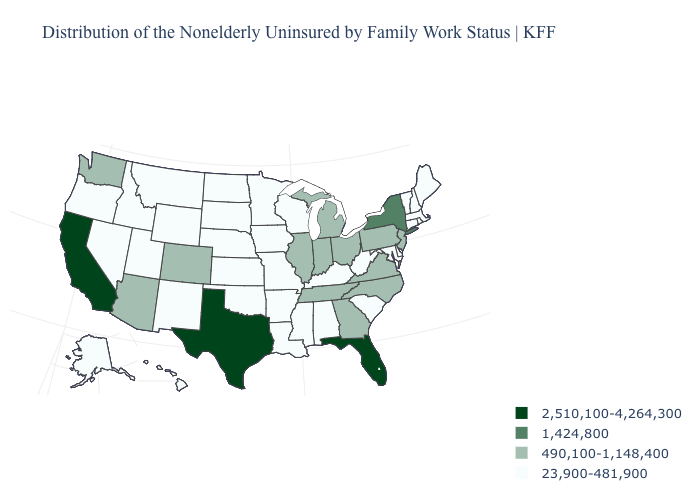Does the map have missing data?
Short answer required. No. How many symbols are there in the legend?
Concise answer only. 4. What is the value of Wisconsin?
Answer briefly. 23,900-481,900. Which states have the lowest value in the USA?
Keep it brief. Alabama, Alaska, Arkansas, Connecticut, Delaware, Hawaii, Idaho, Iowa, Kansas, Kentucky, Louisiana, Maine, Maryland, Massachusetts, Minnesota, Mississippi, Missouri, Montana, Nebraska, Nevada, New Hampshire, New Mexico, North Dakota, Oklahoma, Oregon, Rhode Island, South Carolina, South Dakota, Utah, Vermont, West Virginia, Wisconsin, Wyoming. Does Virginia have a lower value than Florida?
Write a very short answer. Yes. Among the states that border Iowa , does Nebraska have the lowest value?
Be succinct. Yes. Does the map have missing data?
Be succinct. No. What is the value of New York?
Be succinct. 1,424,800. What is the lowest value in the USA?
Concise answer only. 23,900-481,900. Name the states that have a value in the range 1,424,800?
Write a very short answer. New York. Does the first symbol in the legend represent the smallest category?
Keep it brief. No. Does California have the lowest value in the USA?
Write a very short answer. No. Does Kentucky have the lowest value in the South?
Answer briefly. Yes. Name the states that have a value in the range 490,100-1,148,400?
Give a very brief answer. Arizona, Colorado, Georgia, Illinois, Indiana, Michigan, New Jersey, North Carolina, Ohio, Pennsylvania, Tennessee, Virginia, Washington. 